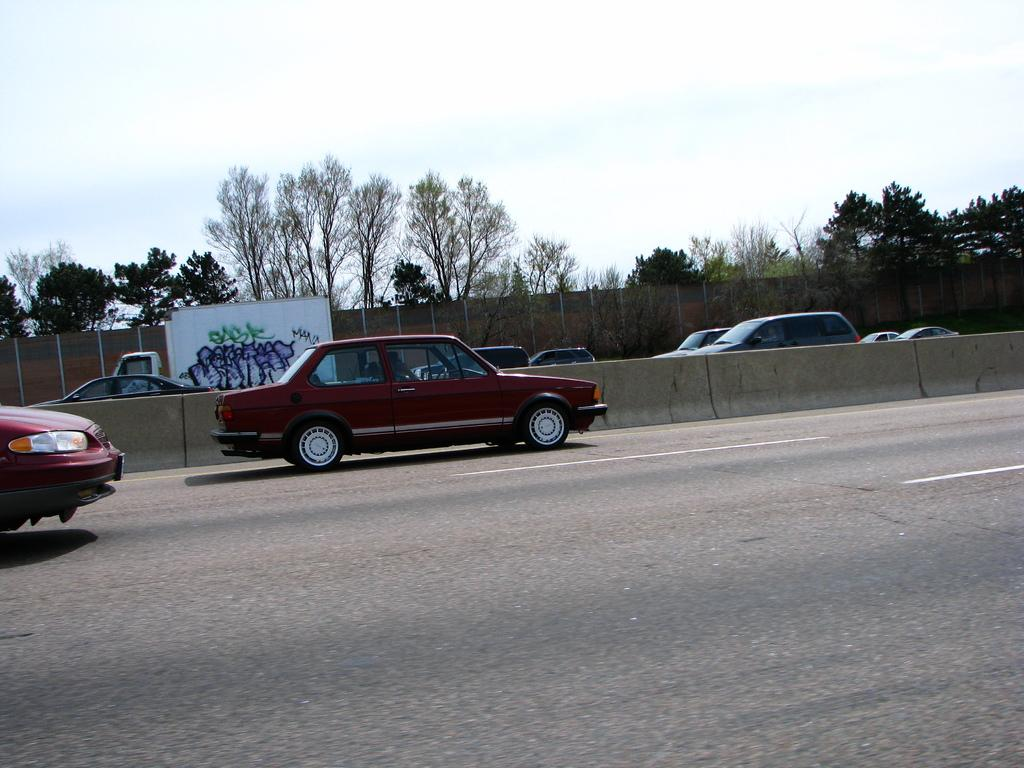What can be seen on the road in the image? There are vehicles on the road in the image. What object is visible in the image that is typically used for writing or displaying information? There is a white board visible in the image. What type of natural vegetation is present in the image? Trees are present in the image. What type of fencing can be seen in the image? Cement fencing is visible in the image. What is the color of the sky in the image? The sky is blue and white in color. Can you hear the sound of an apple being exchanged in the image? There is no sound or exchange of apples present in the image. What type of creature is shown interacting with the trees in the image? There is no creature shown interacting with the trees in the image; only the vehicles, white board, fencing, and sky are present. 